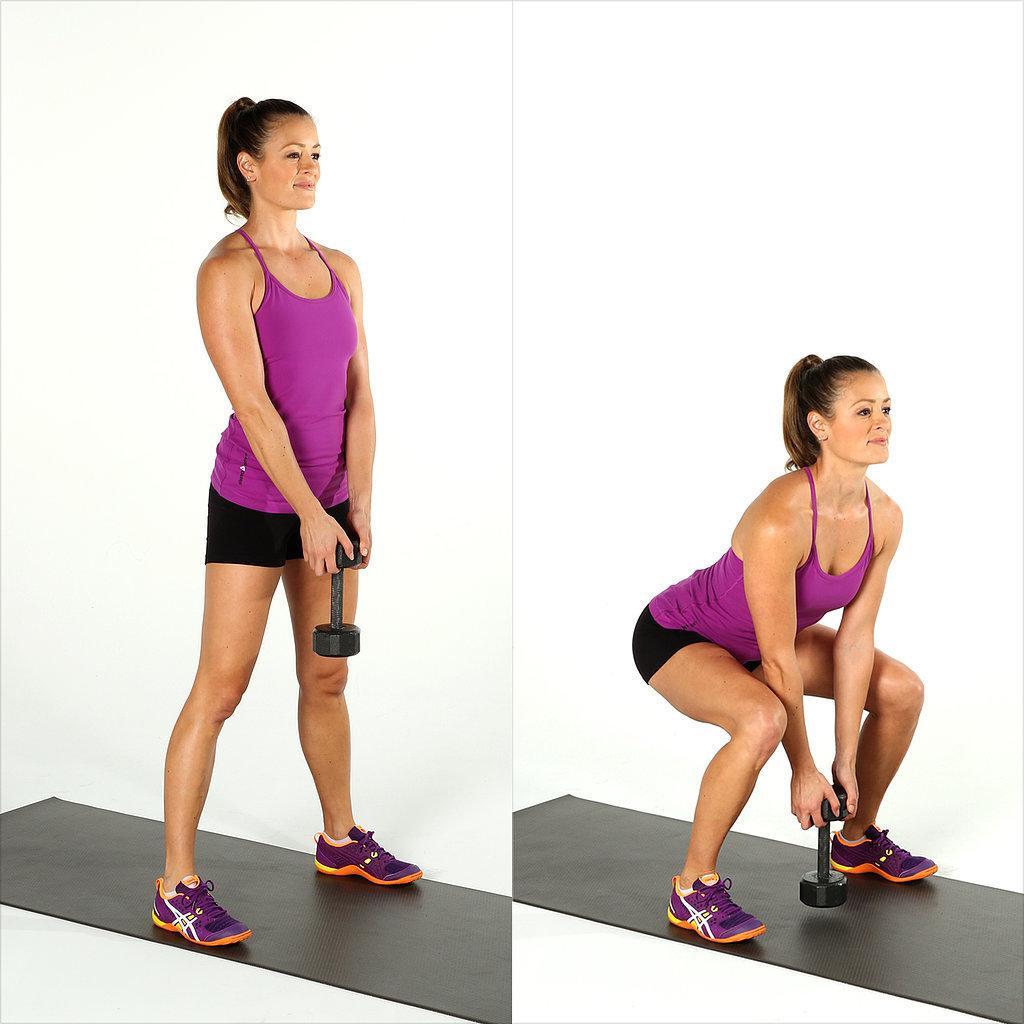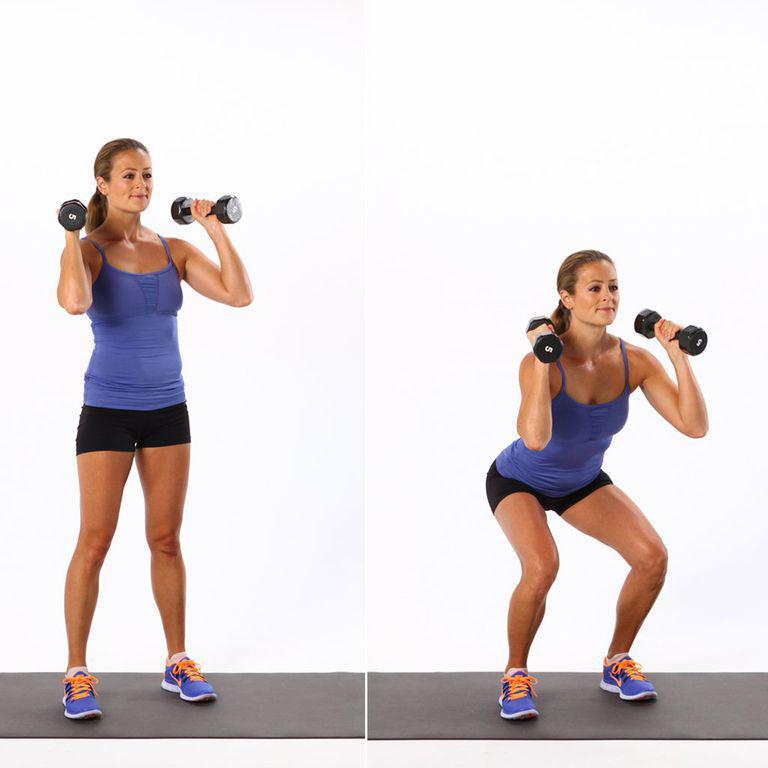The first image is the image on the left, the second image is the image on the right. For the images shown, is this caption "Each image shows two steps of a weight workout, with a standing pose on the left and a crouched pose next to it." true? Answer yes or no. Yes. The first image is the image on the left, the second image is the image on the right. Analyze the images presented: Is the assertion "The left and right image contains the same number of  people working out with weights." valid? Answer yes or no. Yes. 